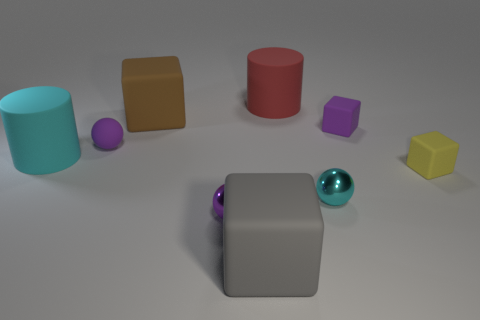What is the size of the block that is the same color as the tiny matte sphere?
Ensure brevity in your answer.  Small. Is the number of small things on the right side of the large red thing greater than the number of tiny purple balls?
Ensure brevity in your answer.  Yes. Are there any cubes that have the same color as the small rubber ball?
Provide a short and direct response. Yes. What is the color of the cube that is the same size as the gray rubber object?
Make the answer very short. Brown. How many gray blocks are behind the small purple thing to the right of the big gray rubber cube?
Offer a very short reply. 0. What number of things are tiny rubber blocks that are behind the small rubber sphere or purple metallic spheres?
Provide a succinct answer. 2. What number of other large objects have the same material as the gray thing?
Give a very brief answer. 3. There is a matte thing that is the same color as the tiny matte sphere; what is its shape?
Your answer should be very brief. Cube. Is the number of gray matte things behind the red matte cylinder the same as the number of yellow blocks?
Your response must be concise. No. How big is the sphere behind the yellow object?
Provide a succinct answer. Small. 